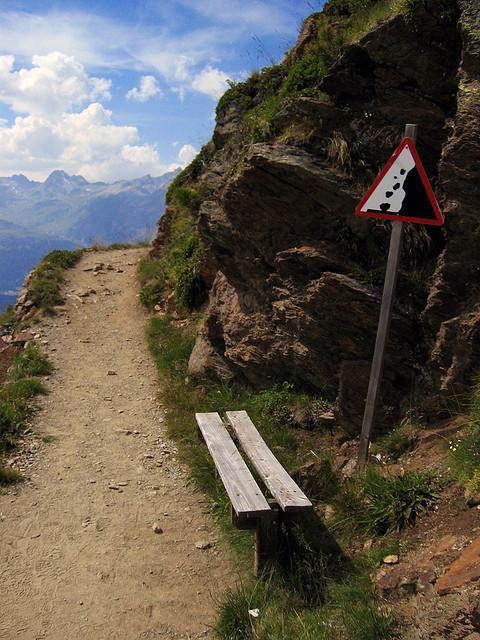How many people are there?
Give a very brief answer. 0. 